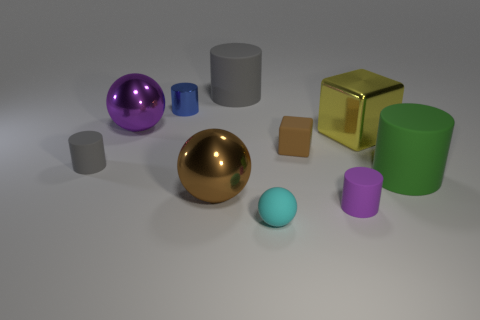How do the textures of the objects compare? Most objects in the image appear to have smooth surfaces with reflective properties, highlighting their metallic texture. This glossiness varies in intensity among the objects, with some exhibiting a mirror-like finish while others have a more subdued reflection. Which object stands out the most to you? The large golden sphere stands out prominently due to its size, central positioning, and the way it catches the light, making it a focal point amidst the other objects. 